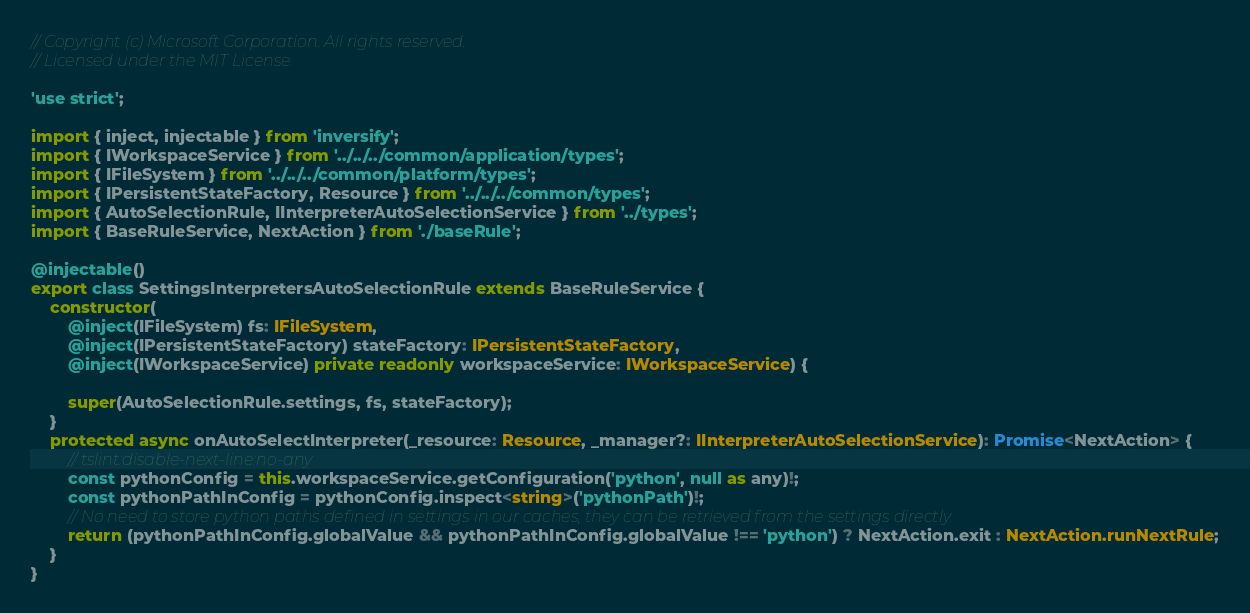<code> <loc_0><loc_0><loc_500><loc_500><_TypeScript_>// Copyright (c) Microsoft Corporation. All rights reserved.
// Licensed under the MIT License.

'use strict';

import { inject, injectable } from 'inversify';
import { IWorkspaceService } from '../../../common/application/types';
import { IFileSystem } from '../../../common/platform/types';
import { IPersistentStateFactory, Resource } from '../../../common/types';
import { AutoSelectionRule, IInterpreterAutoSelectionService } from '../types';
import { BaseRuleService, NextAction } from './baseRule';

@injectable()
export class SettingsInterpretersAutoSelectionRule extends BaseRuleService {
    constructor(
        @inject(IFileSystem) fs: IFileSystem,
        @inject(IPersistentStateFactory) stateFactory: IPersistentStateFactory,
        @inject(IWorkspaceService) private readonly workspaceService: IWorkspaceService) {

        super(AutoSelectionRule.settings, fs, stateFactory);
    }
    protected async onAutoSelectInterpreter(_resource: Resource, _manager?: IInterpreterAutoSelectionService): Promise<NextAction> {
        // tslint:disable-next-line:no-any
        const pythonConfig = this.workspaceService.getConfiguration('python', null as any)!;
        const pythonPathInConfig = pythonConfig.inspect<string>('pythonPath')!;
        // No need to store python paths defined in settings in our caches, they can be retrieved from the settings directly.
        return (pythonPathInConfig.globalValue && pythonPathInConfig.globalValue !== 'python') ? NextAction.exit : NextAction.runNextRule;
    }
}
</code> 